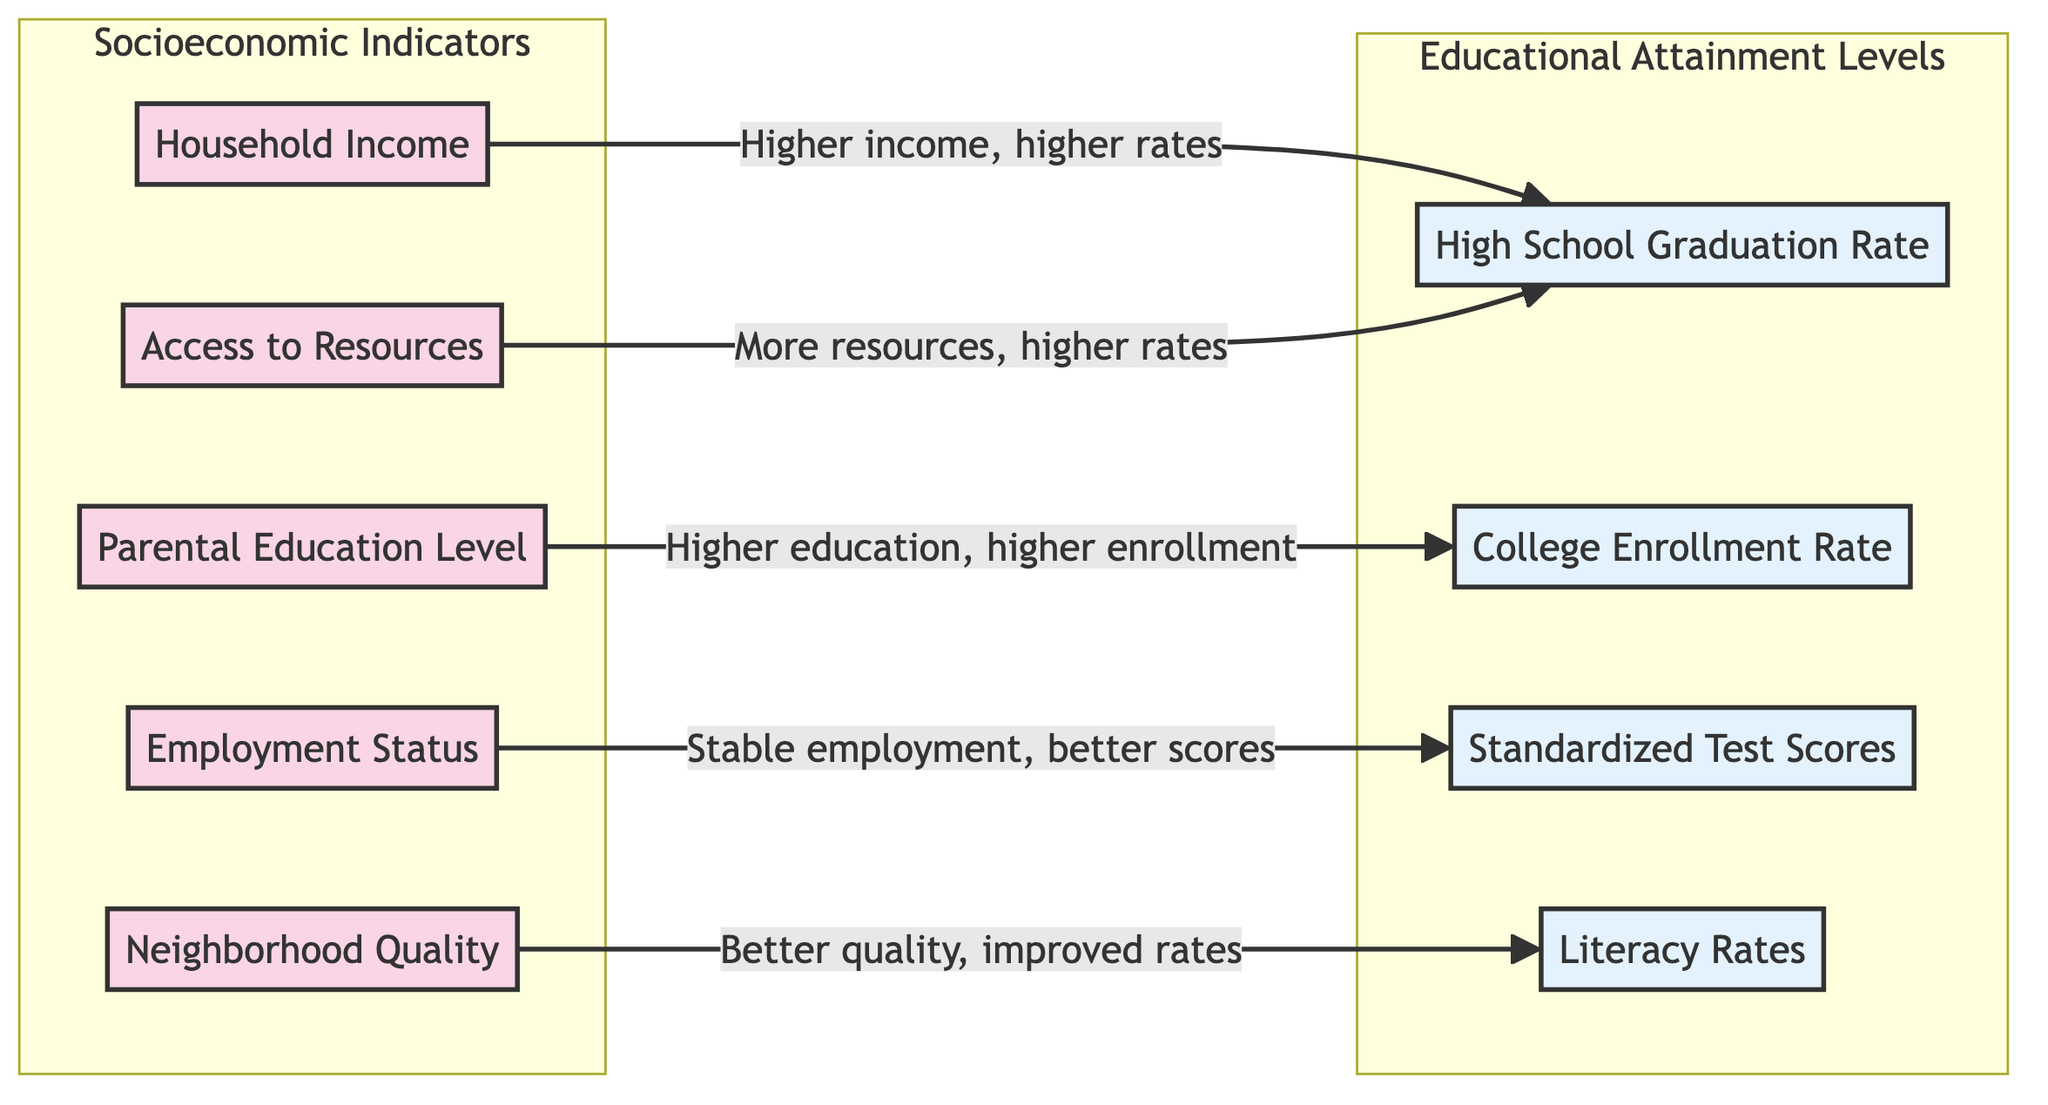What is the main socioeconomic indicator associated with high school graduation rates? The diagram shows that household income is linked to high school graduation rates, with the direction indicating that higher income correlates with higher graduation rates.
Answer: Household Income Which educational attainment level is affected by parental education level? The diagram indicates a direct relationship where higher parental education levels lead to higher college enrollment rates.
Answer: College Enrollment Rate How many socioeconomic indicators are represented in the diagram? By counting the nodes in the "Socioeconomic Indicators" subgraph, there are five indicators listed: Household Income, Parental Education Level, Employment Status, Neighborhood Quality, and Access to Resources.
Answer: Five What effect does neighborhood quality have on literacy rates? The diagram illustrates that better neighborhood quality leads to improved literacy rates, suggestive of a positive correlation between the two.
Answer: Improved rates Which socioeconomic factor is linked to standardized test scores? The diagram specifies that employment status influences standardized test scores, establishing a relationship between stable employment situations and better test outcomes.
Answer: Employment Status Identify the educational attainment level associated with access to resources. The diagram indicates that access to resources correlates with higher high school graduation rates, showing that more resources lead to better outcomes at this educational level.
Answer: High School Graduation Rate What type of relationship exists between parental education level and college enrollment rates? The relationship shown in the diagram indicates a positive correlation where higher parental education levels contribute to higher college enrollment rates.
Answer: Positive If employment status is improved, what is the expected effect on standardized test scores? The diagram suggests that stable employment leads to better standardized test scores, indicating a direct positive impact of improving employment status on educational outcomes.
Answer: Better scores 